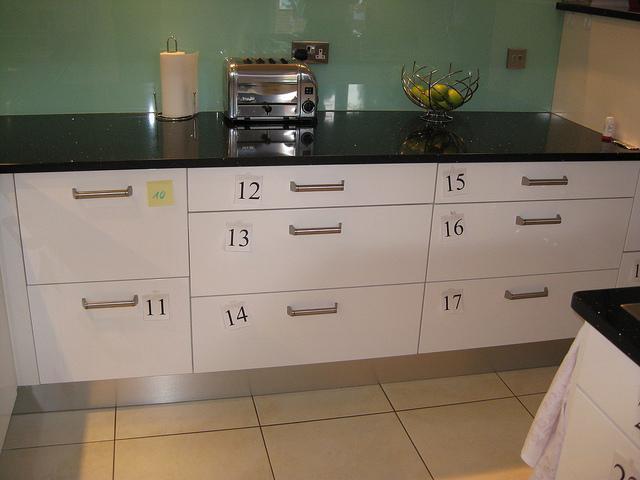How many people are in the photo?
Give a very brief answer. 0. 